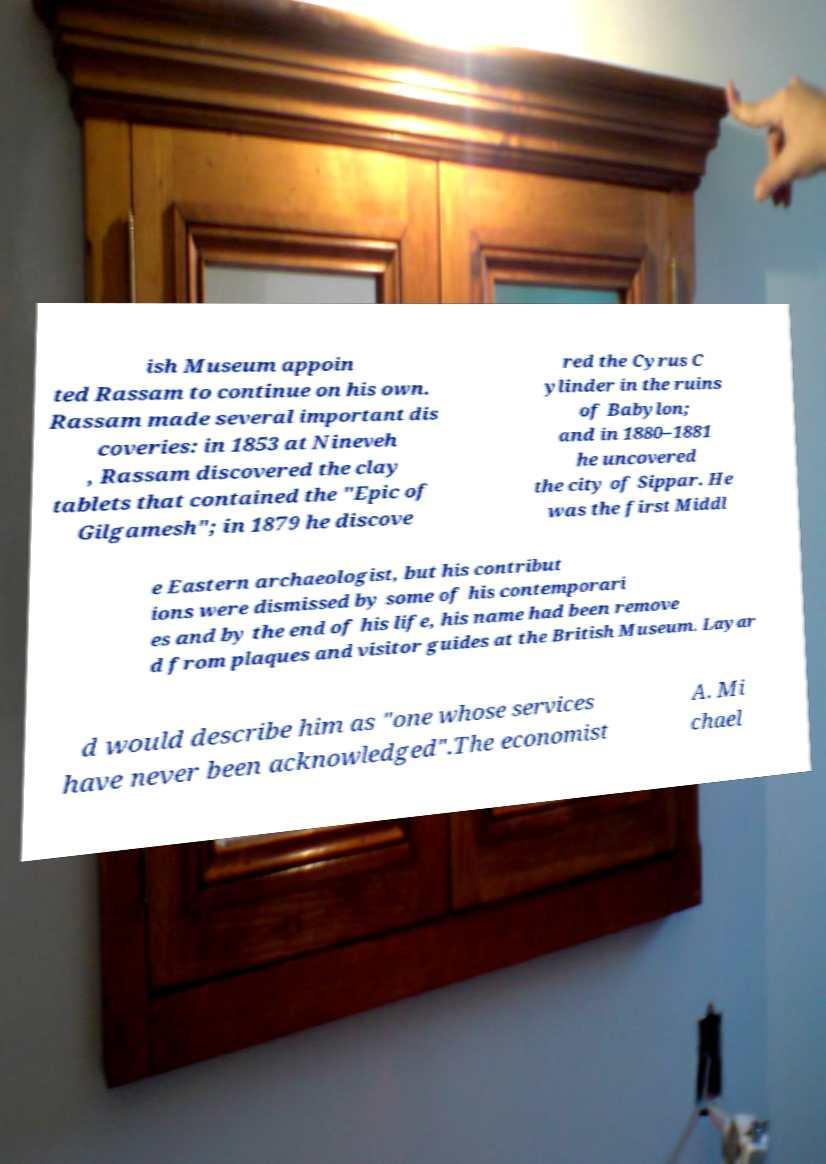I need the written content from this picture converted into text. Can you do that? ish Museum appoin ted Rassam to continue on his own. Rassam made several important dis coveries: in 1853 at Nineveh , Rassam discovered the clay tablets that contained the "Epic of Gilgamesh"; in 1879 he discove red the Cyrus C ylinder in the ruins of Babylon; and in 1880–1881 he uncovered the city of Sippar. He was the first Middl e Eastern archaeologist, but his contribut ions were dismissed by some of his contemporari es and by the end of his life, his name had been remove d from plaques and visitor guides at the British Museum. Layar d would describe him as "one whose services have never been acknowledged".The economist A. Mi chael 